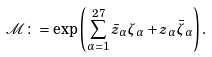Convert formula to latex. <formula><loc_0><loc_0><loc_500><loc_500>\mathcal { M } \colon = \exp \left ( \sum _ { \alpha = 1 } ^ { 2 7 } \bar { z } _ { \alpha } \zeta _ { \alpha } + z _ { \alpha } \bar { \zeta } _ { \alpha } \right ) .</formula> 